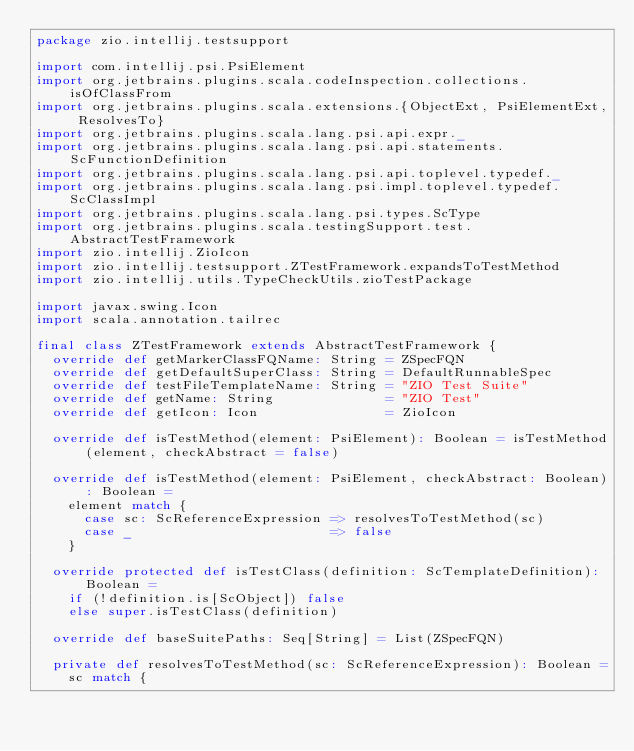Convert code to text. <code><loc_0><loc_0><loc_500><loc_500><_Scala_>package zio.intellij.testsupport

import com.intellij.psi.PsiElement
import org.jetbrains.plugins.scala.codeInspection.collections.isOfClassFrom
import org.jetbrains.plugins.scala.extensions.{ObjectExt, PsiElementExt, ResolvesTo}
import org.jetbrains.plugins.scala.lang.psi.api.expr._
import org.jetbrains.plugins.scala.lang.psi.api.statements.ScFunctionDefinition
import org.jetbrains.plugins.scala.lang.psi.api.toplevel.typedef._
import org.jetbrains.plugins.scala.lang.psi.impl.toplevel.typedef.ScClassImpl
import org.jetbrains.plugins.scala.lang.psi.types.ScType
import org.jetbrains.plugins.scala.testingSupport.test.AbstractTestFramework
import zio.intellij.ZioIcon
import zio.intellij.testsupport.ZTestFramework.expandsToTestMethod
import zio.intellij.utils.TypeCheckUtils.zioTestPackage

import javax.swing.Icon
import scala.annotation.tailrec

final class ZTestFramework extends AbstractTestFramework {
  override def getMarkerClassFQName: String = ZSpecFQN
  override def getDefaultSuperClass: String = DefaultRunnableSpec
  override def testFileTemplateName: String = "ZIO Test Suite"
  override def getName: String              = "ZIO Test"
  override def getIcon: Icon                = ZioIcon

  override def isTestMethod(element: PsiElement): Boolean = isTestMethod(element, checkAbstract = false)

  override def isTestMethod(element: PsiElement, checkAbstract: Boolean): Boolean =
    element match {
      case sc: ScReferenceExpression => resolvesToTestMethod(sc)
      case _                         => false
    }

  override protected def isTestClass(definition: ScTemplateDefinition): Boolean =
    if (!definition.is[ScObject]) false
    else super.isTestClass(definition)

  override def baseSuitePaths: Seq[String] = List(ZSpecFQN)

  private def resolvesToTestMethod(sc: ScReferenceExpression): Boolean =
    sc match {</code> 